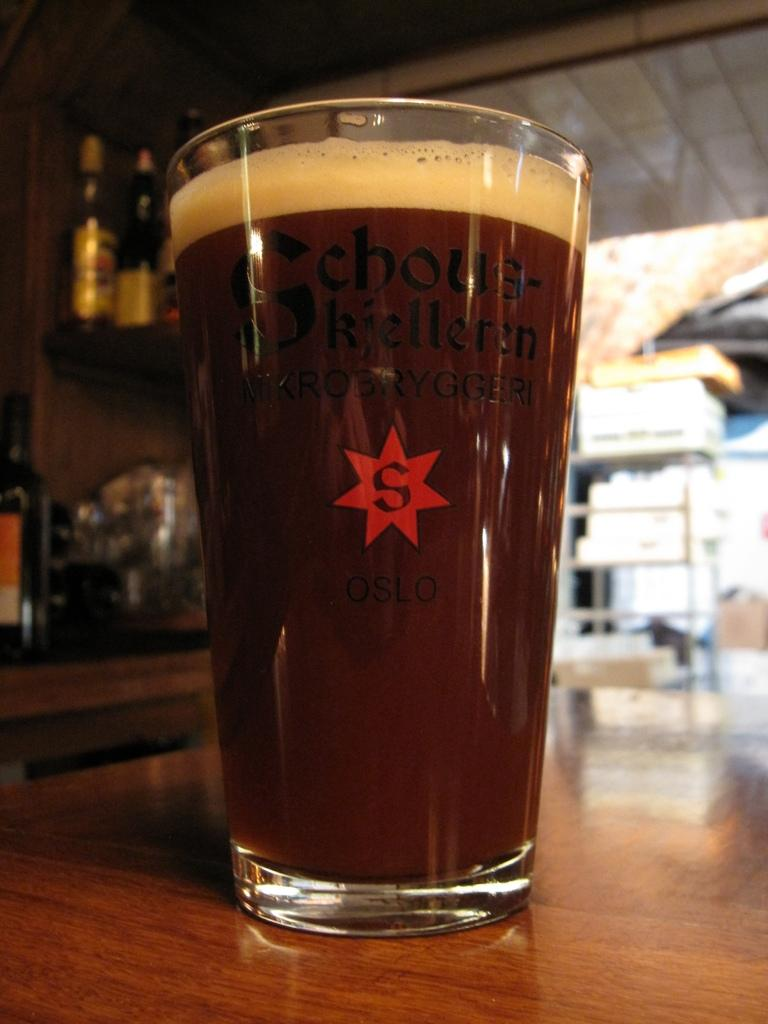What is in the glass that is visible in the image? There is a glass with liquid in the image. What is the glass placed on? The glass is on a wooden object. What can be seen behind the glass in the image? There are bottles and other objects visible behind the glass. What type of texture does the ice have in the image? There is no ice present in the image, so it is not possible to determine the texture of any ice. 